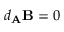<formula> <loc_0><loc_0><loc_500><loc_500>d _ { A } B = 0</formula> 